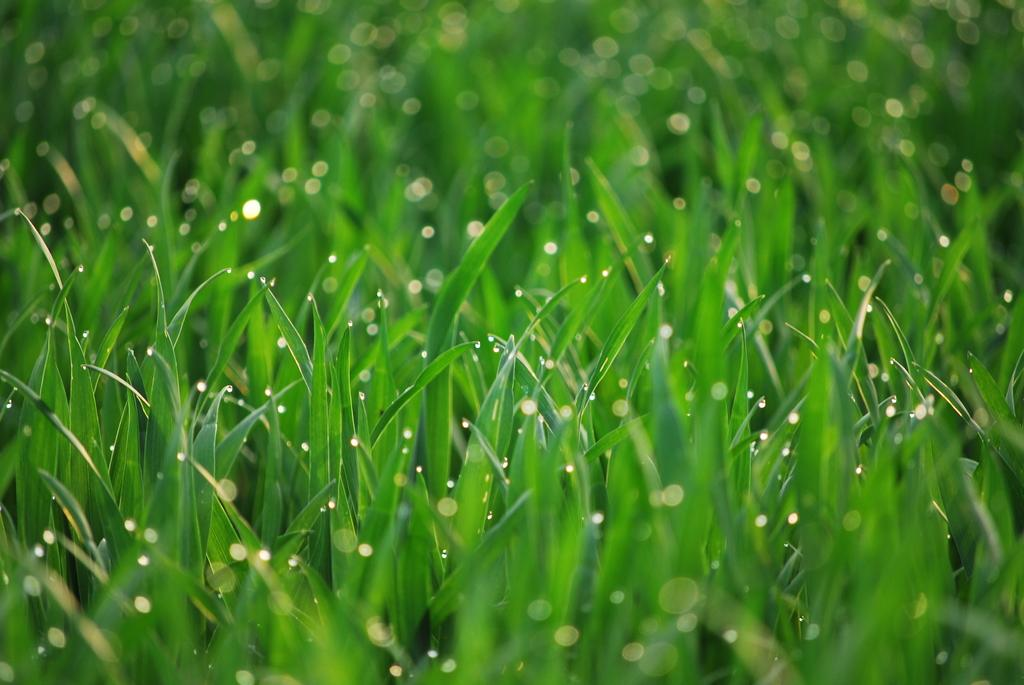What is present on the grass in the image? There are water drops on the grass in the image. What type of activity can be seen involving boats in the image? There are no boats or any activity involving boats present in the image. 